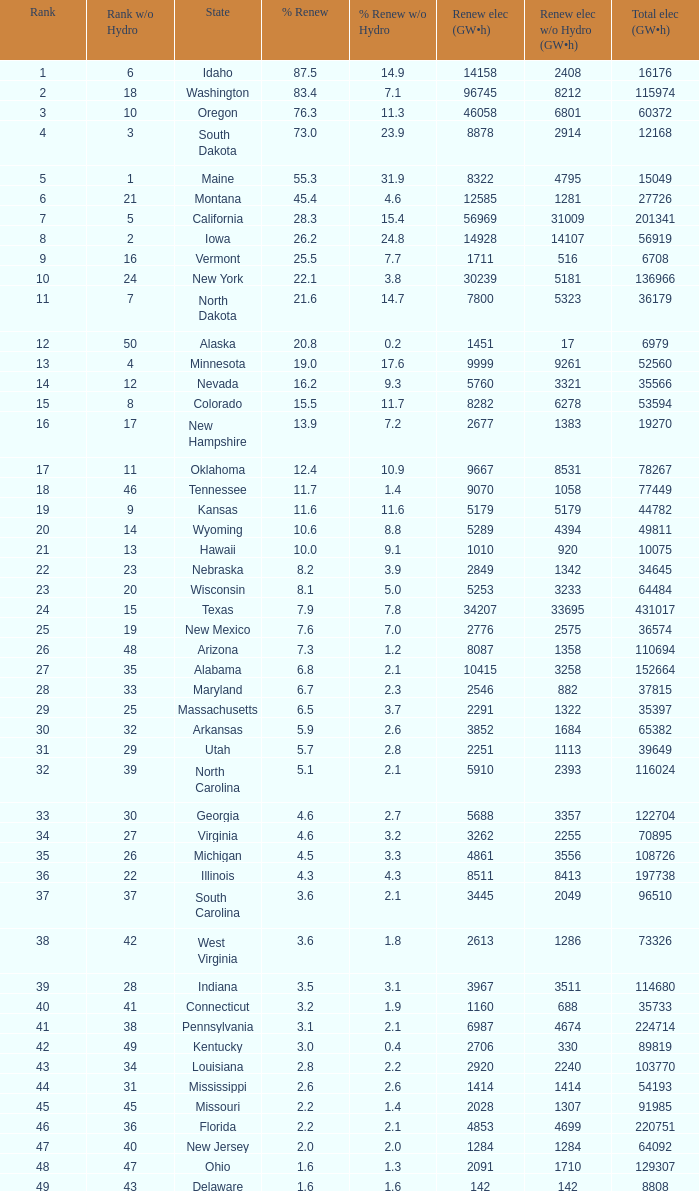When green electricity reaches 5760 (gw×h), what is the smallest amount of sustainable electricity without hydrogen energy? 3321.0. 